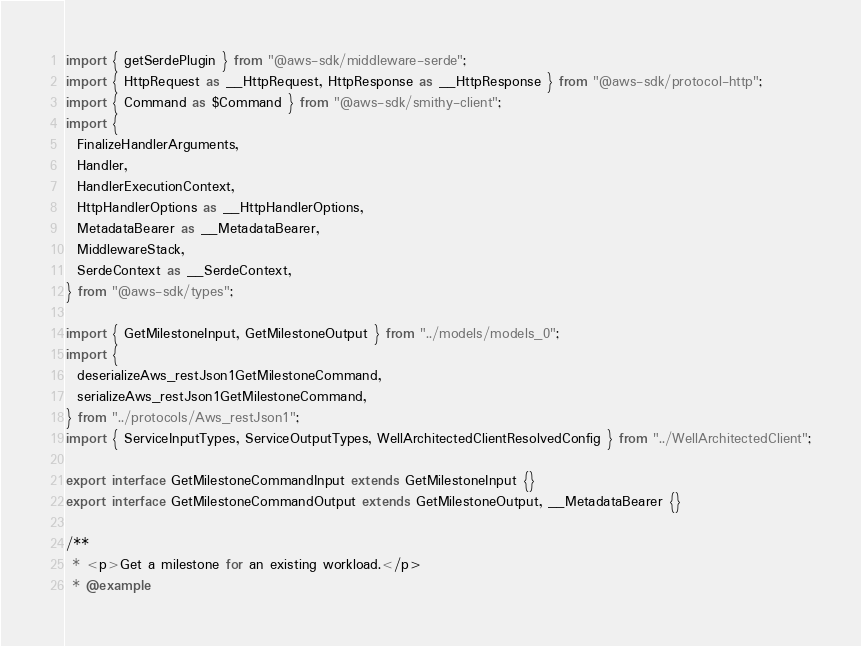Convert code to text. <code><loc_0><loc_0><loc_500><loc_500><_TypeScript_>import { getSerdePlugin } from "@aws-sdk/middleware-serde";
import { HttpRequest as __HttpRequest, HttpResponse as __HttpResponse } from "@aws-sdk/protocol-http";
import { Command as $Command } from "@aws-sdk/smithy-client";
import {
  FinalizeHandlerArguments,
  Handler,
  HandlerExecutionContext,
  HttpHandlerOptions as __HttpHandlerOptions,
  MetadataBearer as __MetadataBearer,
  MiddlewareStack,
  SerdeContext as __SerdeContext,
} from "@aws-sdk/types";

import { GetMilestoneInput, GetMilestoneOutput } from "../models/models_0";
import {
  deserializeAws_restJson1GetMilestoneCommand,
  serializeAws_restJson1GetMilestoneCommand,
} from "../protocols/Aws_restJson1";
import { ServiceInputTypes, ServiceOutputTypes, WellArchitectedClientResolvedConfig } from "../WellArchitectedClient";

export interface GetMilestoneCommandInput extends GetMilestoneInput {}
export interface GetMilestoneCommandOutput extends GetMilestoneOutput, __MetadataBearer {}

/**
 * <p>Get a milestone for an existing workload.</p>
 * @example</code> 